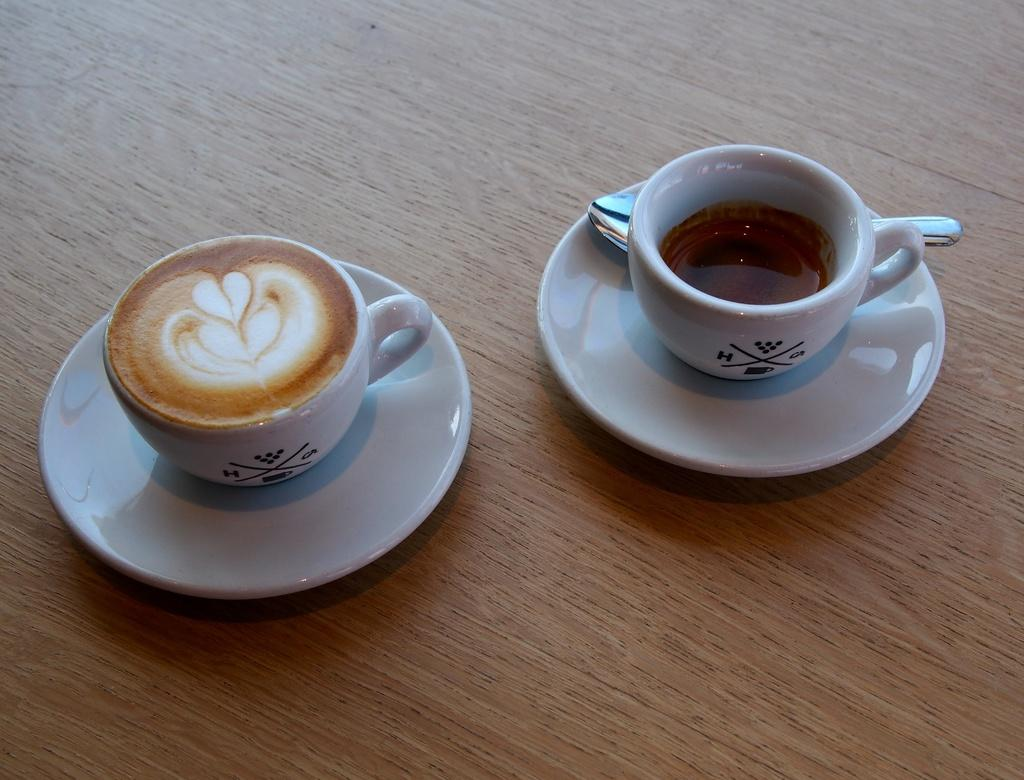What type of dishware is visible in the image? There are cups and plates in the image. Where are the cups and plates located? The cups and plates are on a table. What type of land is depicted in the image? There is no land depicted in the image; it features cups and plates on a table. What religion is practiced by the people in the image? There is no indication of any religious practice or belief in the image, as it only shows cups and plates on a table. 